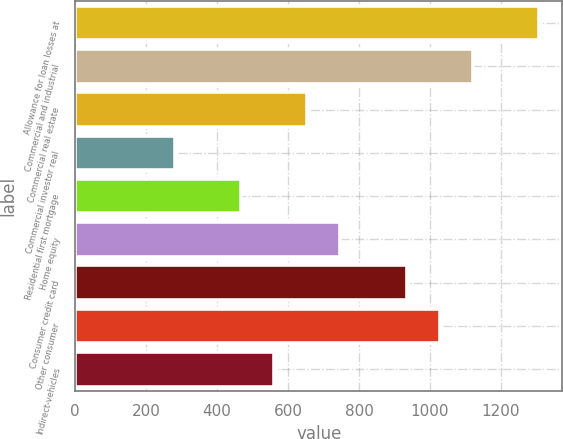<chart> <loc_0><loc_0><loc_500><loc_500><bar_chart><fcel>Allowance for loan losses at<fcel>Commercial and industrial<fcel>Commercial real estate<fcel>Commercial investor real<fcel>Residential first mortgage<fcel>Home equity<fcel>Consumer credit card<fcel>Other consumer<fcel>Indirect-vehicles<nl><fcel>1307.44<fcel>1120.72<fcel>653.92<fcel>280.48<fcel>467.2<fcel>747.28<fcel>934<fcel>1027.36<fcel>560.56<nl></chart> 